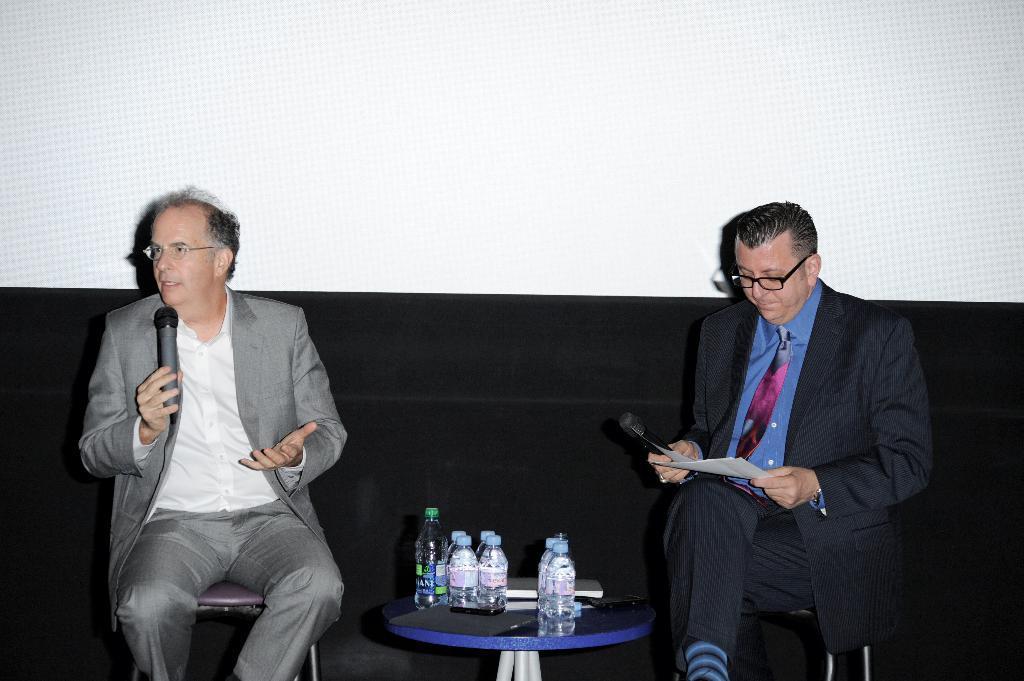Please provide a concise description of this image. In this image I can see two people are sitting. I can see few bottles and few objects. Background is in black and white color. 